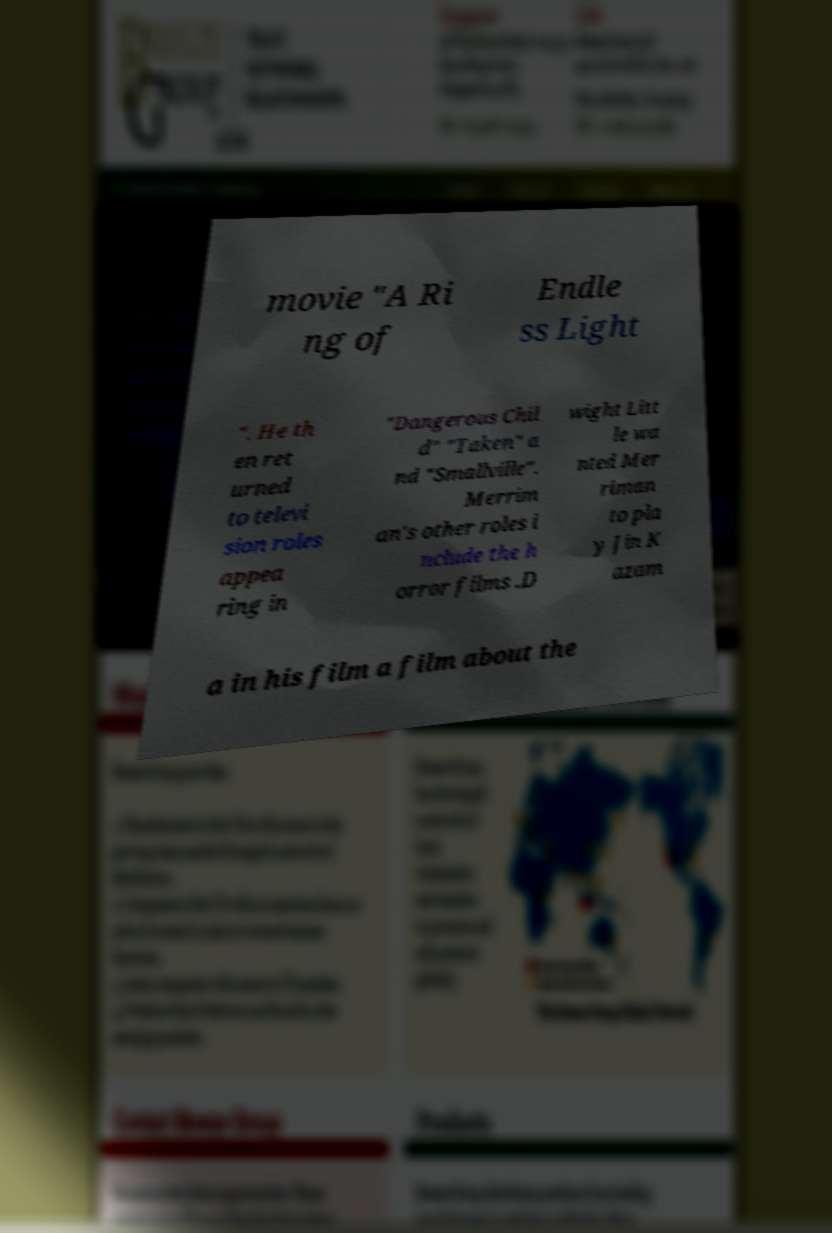Could you assist in decoding the text presented in this image and type it out clearly? movie "A Ri ng of Endle ss Light ". He th en ret urned to televi sion roles appea ring in "Dangerous Chil d" "Taken" a nd "Smallville". Merrim an's other roles i nclude the h orror films .D wight Litt le wa nted Mer riman to pla y Jin K azam a in his film a film about the 